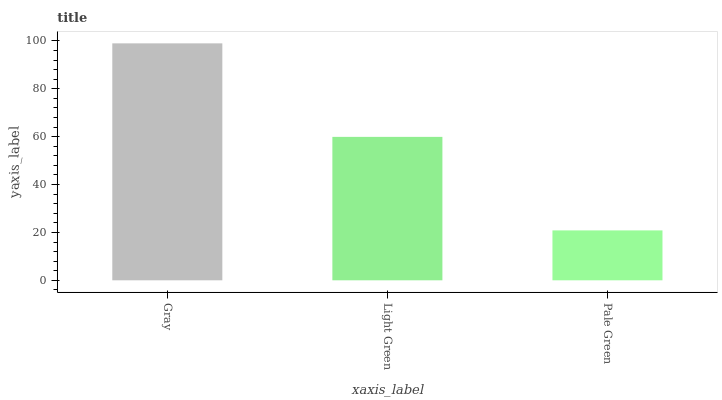Is Pale Green the minimum?
Answer yes or no. Yes. Is Gray the maximum?
Answer yes or no. Yes. Is Light Green the minimum?
Answer yes or no. No. Is Light Green the maximum?
Answer yes or no. No. Is Gray greater than Light Green?
Answer yes or no. Yes. Is Light Green less than Gray?
Answer yes or no. Yes. Is Light Green greater than Gray?
Answer yes or no. No. Is Gray less than Light Green?
Answer yes or no. No. Is Light Green the high median?
Answer yes or no. Yes. Is Light Green the low median?
Answer yes or no. Yes. Is Gray the high median?
Answer yes or no. No. Is Gray the low median?
Answer yes or no. No. 